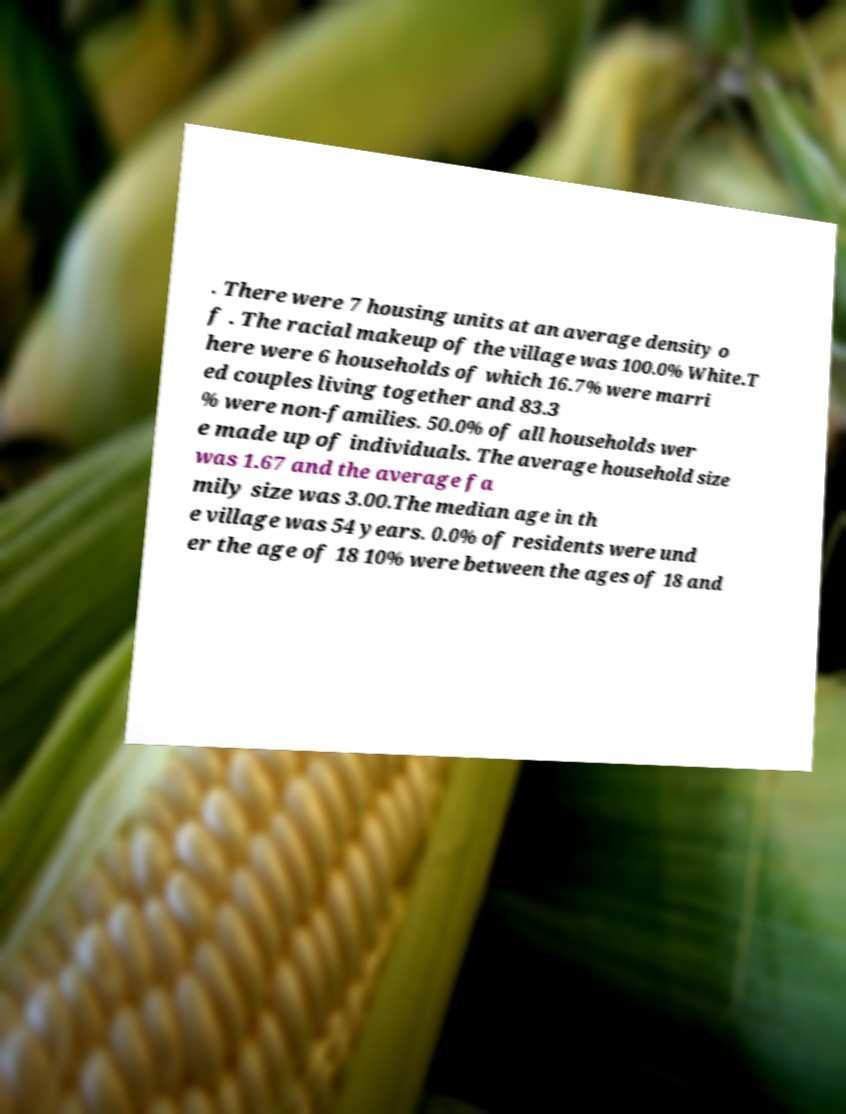Could you extract and type out the text from this image? . There were 7 housing units at an average density o f . The racial makeup of the village was 100.0% White.T here were 6 households of which 16.7% were marri ed couples living together and 83.3 % were non-families. 50.0% of all households wer e made up of individuals. The average household size was 1.67 and the average fa mily size was 3.00.The median age in th e village was 54 years. 0.0% of residents were und er the age of 18 10% were between the ages of 18 and 